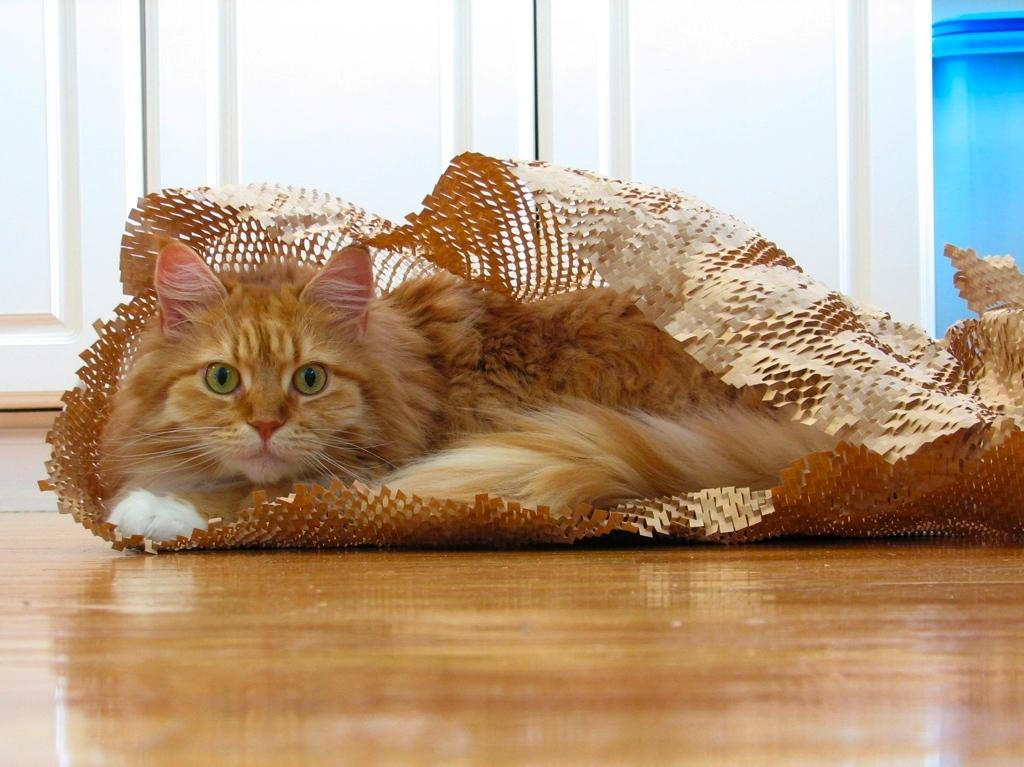What type of animal is in the image? There is a cat in the image. What is the cat lying on? The cat is lying on a paper. What type of surface is visible in the image? There is a floor visible in the image. What architectural feature can be seen in the background? There is a door in the background of the image. What type of wrench is the cat using to fix the spacecraft in the image? There is no wrench or spacecraft present in the image; it features a cat lying on a paper. 